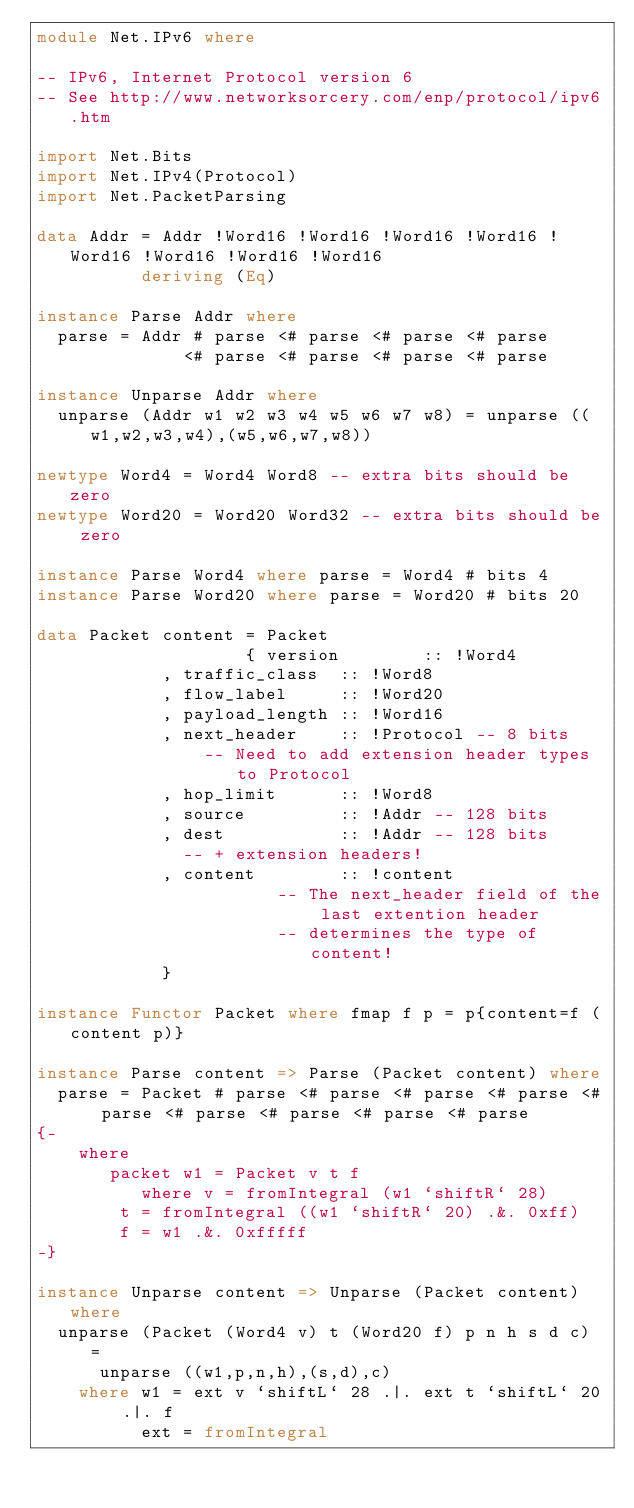Convert code to text. <code><loc_0><loc_0><loc_500><loc_500><_Haskell_>module Net.IPv6 where

-- IPv6, Internet Protocol version 6
-- See http://www.networksorcery.com/enp/protocol/ipv6.htm

import Net.Bits
import Net.IPv4(Protocol)
import Net.PacketParsing

data Addr = Addr !Word16 !Word16 !Word16 !Word16 !Word16 !Word16 !Word16 !Word16
          deriving (Eq)

instance Parse Addr where
  parse = Addr # parse <# parse <# parse <# parse
              <# parse <# parse <# parse <# parse

instance Unparse Addr where
  unparse (Addr w1 w2 w3 w4 w5 w6 w7 w8) = unparse ((w1,w2,w3,w4),(w5,w6,w7,w8))

newtype Word4 = Word4 Word8 -- extra bits should be zero
newtype Word20 = Word20 Word32 -- extra bits should be zero

instance Parse Word4 where parse = Word4 # bits 4
instance Parse Word20 where parse = Word20 # bits 20

data Packet content = Packet
                    { version        :: !Word4
		    , traffic_class  :: !Word8
		    , flow_label     :: !Word20
		    , payload_length :: !Word16
		    , next_header    :: !Protocol -- 8 bits
		        -- Need to add extension header types to Protocol
		    , hop_limit      :: !Word8
		    , source         :: !Addr -- 128 bits
		    , dest           :: !Addr -- 128 bits
		      -- + extension headers!
		    , content        :: !content
                       -- The next_header field of the last extention header
                       -- determines the type of content!
		    }

instance Functor Packet where fmap f p = p{content=f (content p)}

instance Parse content => Parse (Packet content) where
  parse = Packet # parse <# parse <# parse <# parse <# parse <# parse <# parse <# parse <# parse
{-
    where
       packet w1 = Packet v t f
          where v = fromIntegral (w1 `shiftR` 28)
		t = fromIntegral ((w1 `shiftR` 20) .&. 0xff)
		f = w1 .&. 0xfffff
-}

instance Unparse content => Unparse (Packet content) where
  unparse (Packet (Word4 v) t (Word20 f) p n h s d c) =
      unparse ((w1,p,n,h),(s,d),c)
    where w1 = ext v `shiftL` 28 .|. ext t `shiftL` 20 .|. f
          ext = fromIntegral
</code> 